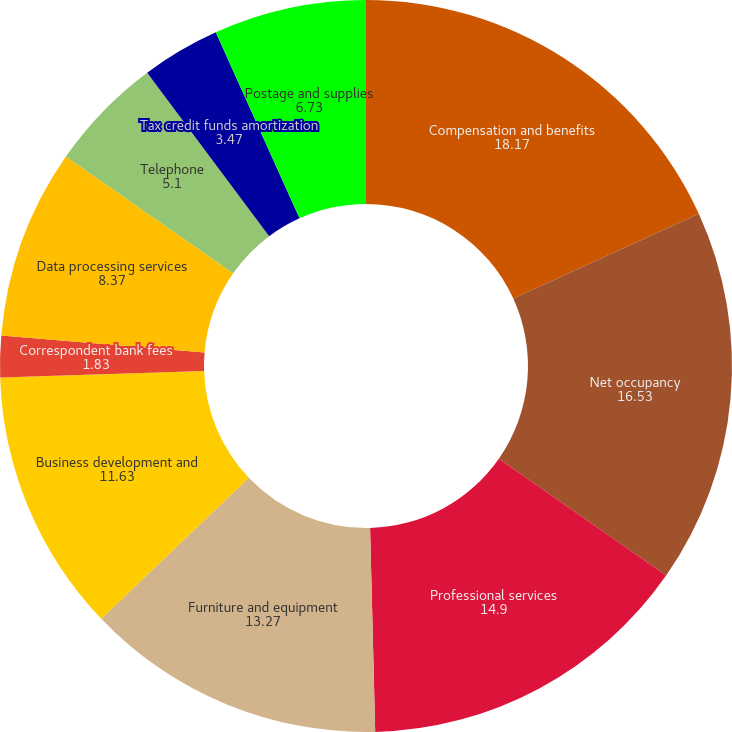Convert chart to OTSL. <chart><loc_0><loc_0><loc_500><loc_500><pie_chart><fcel>Compensation and benefits<fcel>Net occupancy<fcel>Professional services<fcel>Furniture and equipment<fcel>Business development and<fcel>Correspondent bank fees<fcel>Data processing services<fcel>Telephone<fcel>Tax credit funds amortization<fcel>Postage and supplies<nl><fcel>18.17%<fcel>16.53%<fcel>14.9%<fcel>13.27%<fcel>11.63%<fcel>1.83%<fcel>8.37%<fcel>5.1%<fcel>3.47%<fcel>6.73%<nl></chart> 